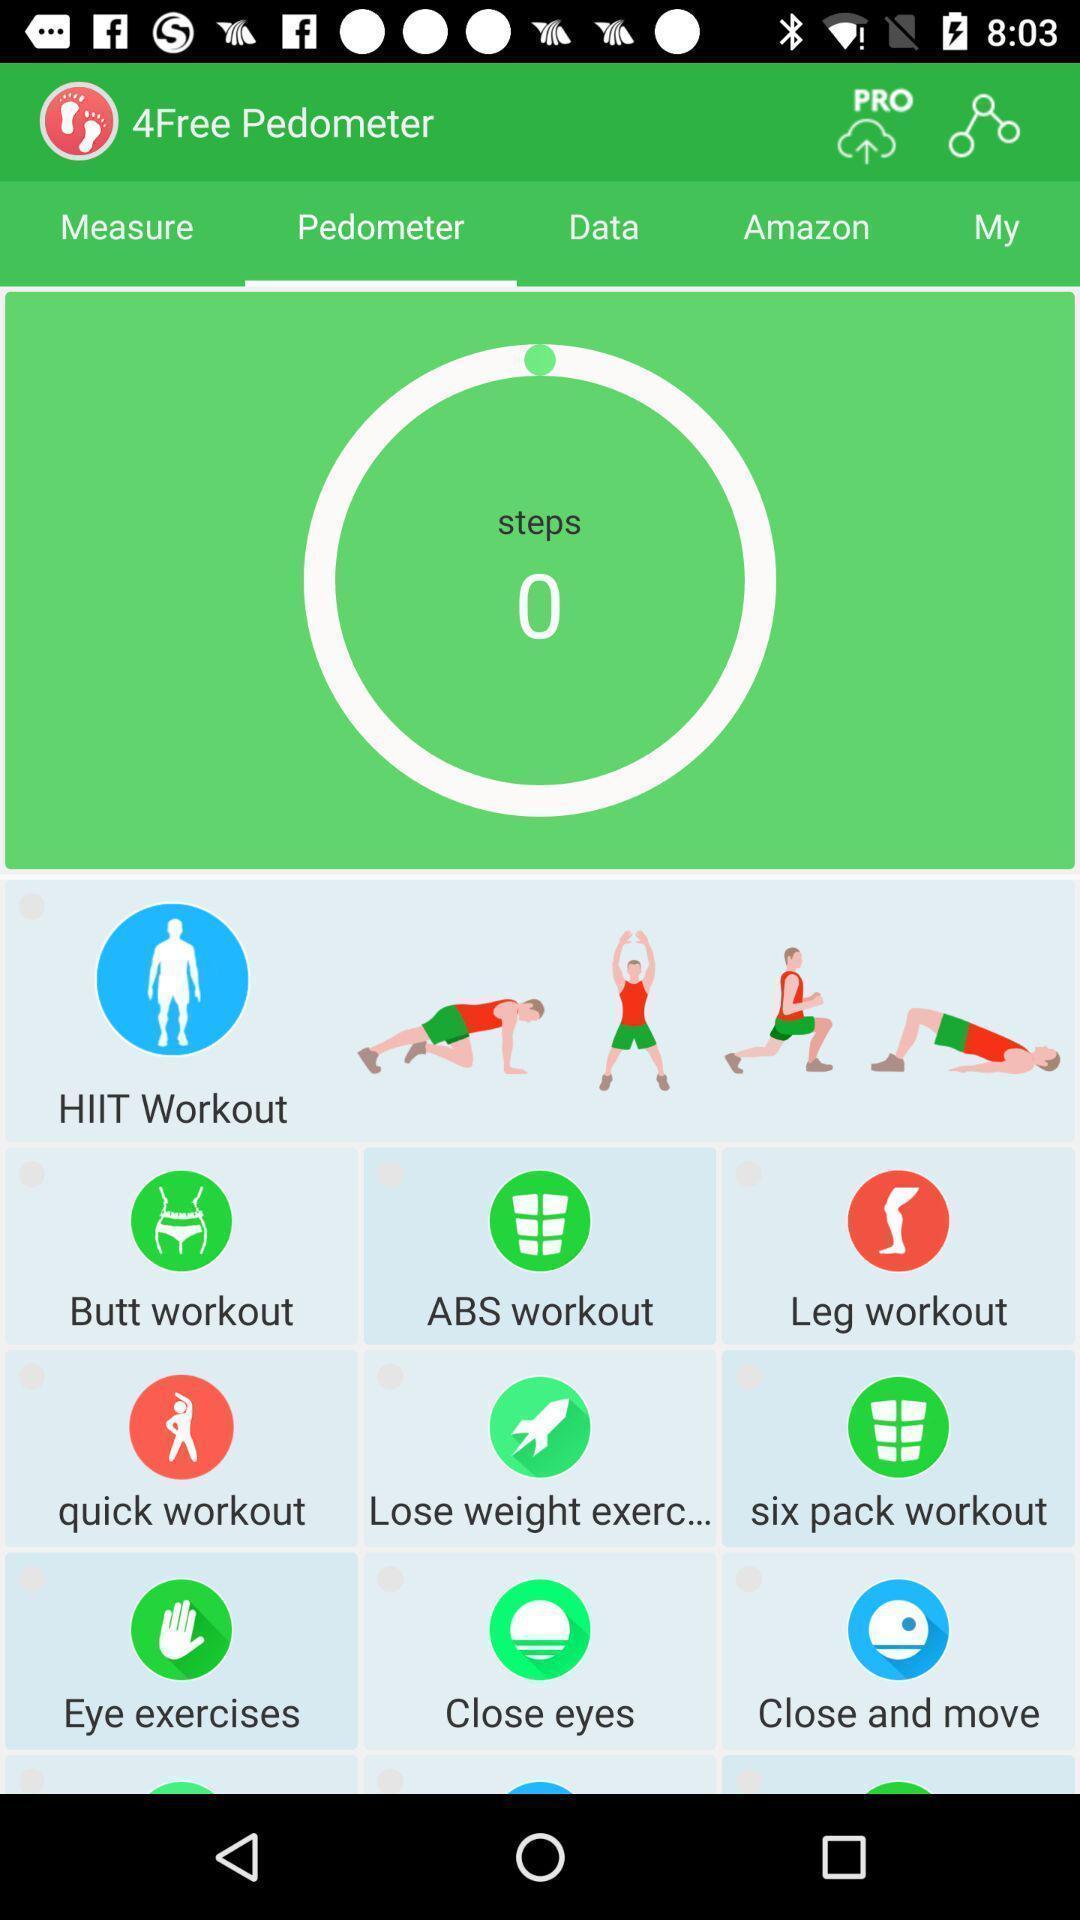Describe the content in this image. Screen displaying the page of a fitness app. 